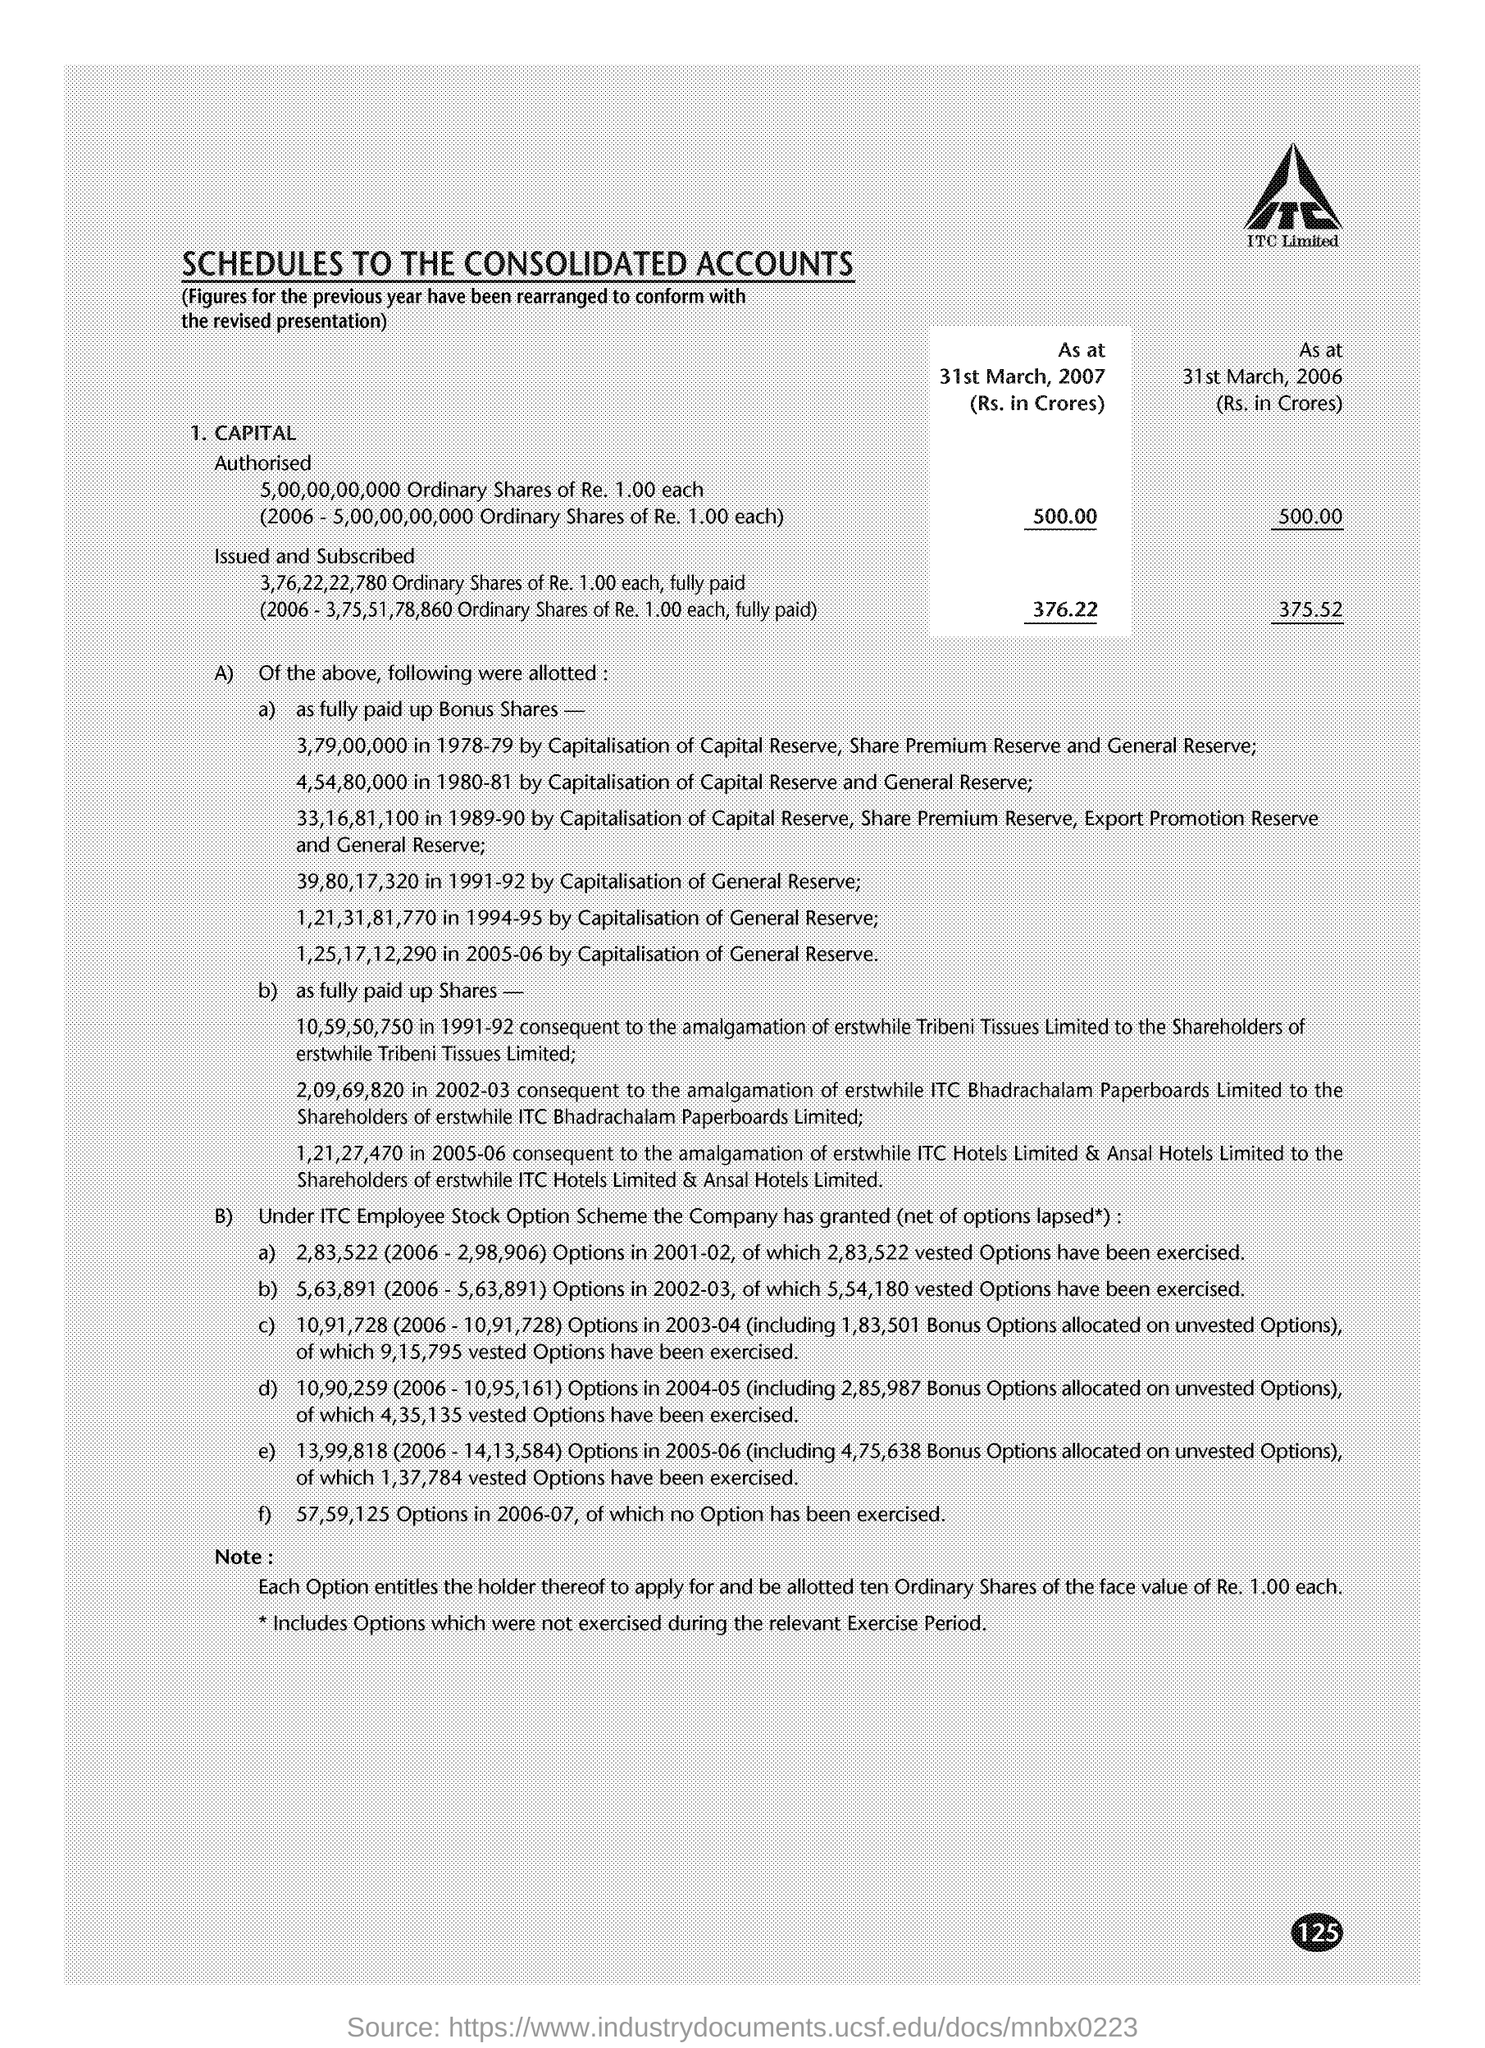What is the Authorised Capital as on 31st March 2007?
Offer a very short reply. 500. What is total of Issued and subscribed capital on 31st March 2006 ?
Your answer should be very brief. 375.52. What is the face value of one ordinary share?
Your answer should be compact. Re 1.00. 